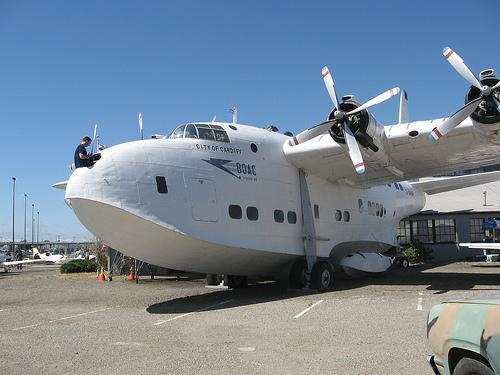How many orange cones are visible?
Give a very brief answer. 2. 